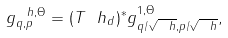<formula> <loc_0><loc_0><loc_500><loc_500>g ^ { \ h , \Theta } _ { q , p } = ( T ^ { \ } h _ { d } ) ^ { * } g ^ { 1 , \Theta } _ { q / \sqrt { \ h } , p / \sqrt { \ h } } ,</formula> 